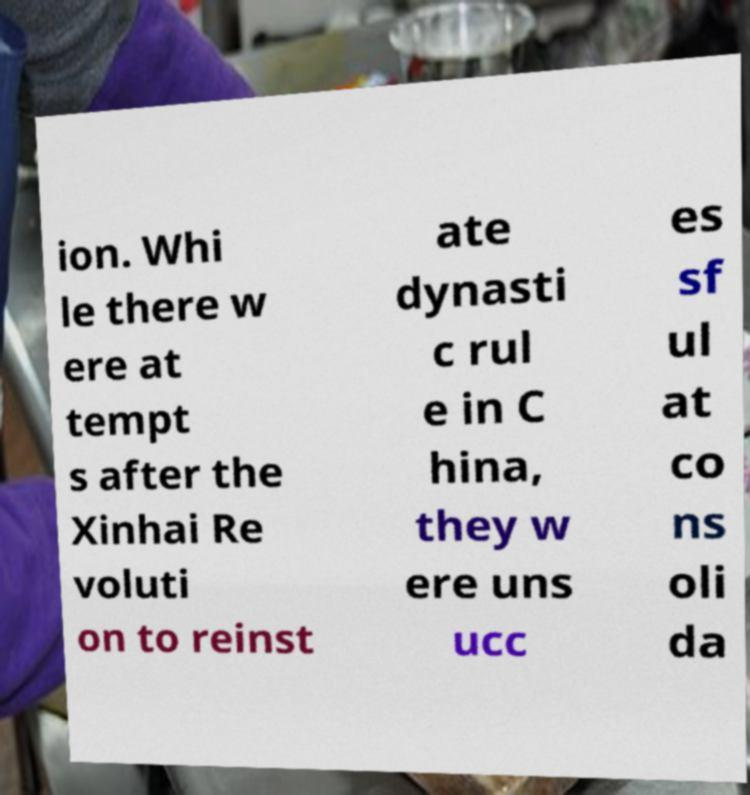Please read and relay the text visible in this image. What does it say? ion. Whi le there w ere at tempt s after the Xinhai Re voluti on to reinst ate dynasti c rul e in C hina, they w ere uns ucc es sf ul at co ns oli da 